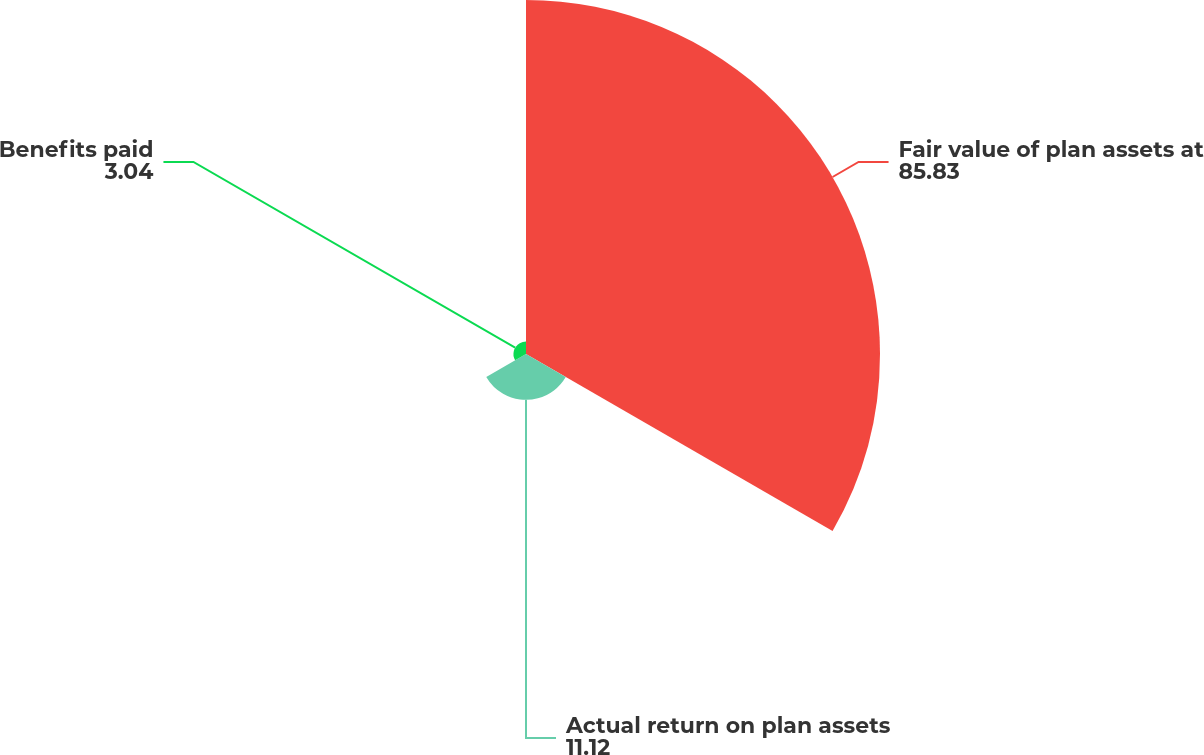Convert chart. <chart><loc_0><loc_0><loc_500><loc_500><pie_chart><fcel>Fair value of plan assets at<fcel>Actual return on plan assets<fcel>Benefits paid<nl><fcel>85.83%<fcel>11.12%<fcel>3.04%<nl></chart> 